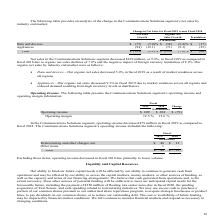According to Te Connectivity's financial document, What was the change in operating income in the Communications Solutions segment in 2019? decreased $79 million. The document states: "ommunications Solutions segment, operating income decreased $79 million in fiscal 2019 as compared to..." Also, Why did operating income decrease in fiscal 2019? due primarily to lower volume.. The document states: "e items, operating income decreased in fiscal 2019 due primarily to lower volume...." Also, What are the items under the operating income in the Communications Solutions segment? The document shows two values: Restructuring and other charges, net and Other items. From the document: "Restructuring and other charges, net $ 48 $ 13 Other items 1 —..." Additionally, In which year was Restructuring and other charges, net larger? According to the financial document, 2019. The relevant text states: "Change in Net Sales for Fiscal 2019 versus Fiscal 2018..." Also, can you calculate: What was the change in Total operating income in the Communications Solutions segment in 2019 from 2018? Based on the calculation: 49-13, the result is 36 (in millions). This is based on the information: "Total $ 49 $ 13 Total $ 49 $ 13..." The key data points involved are: 13, 49. Also, can you calculate: What was the percentage change in Total operating income in the Communications Solutions segment in 2019 from 2018? To answer this question, I need to perform calculations using the financial data. The calculation is: (49-13)/13, which equals 276.92 (percentage). This is based on the information: "Total $ 49 $ 13 Total $ 49 $ 13..." The key data points involved are: 13, 49. 